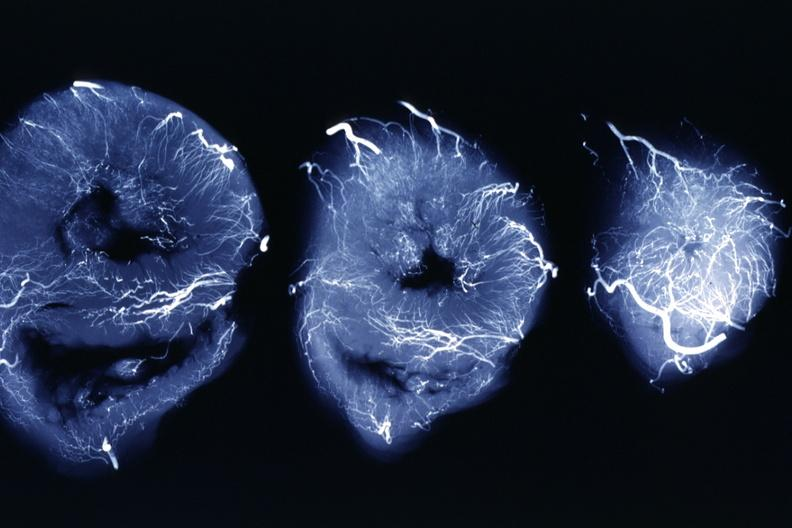does liver show x-ray three horizontal slices of ventricles showing quite well the penetrating arteries?
Answer the question using a single word or phrase. No 